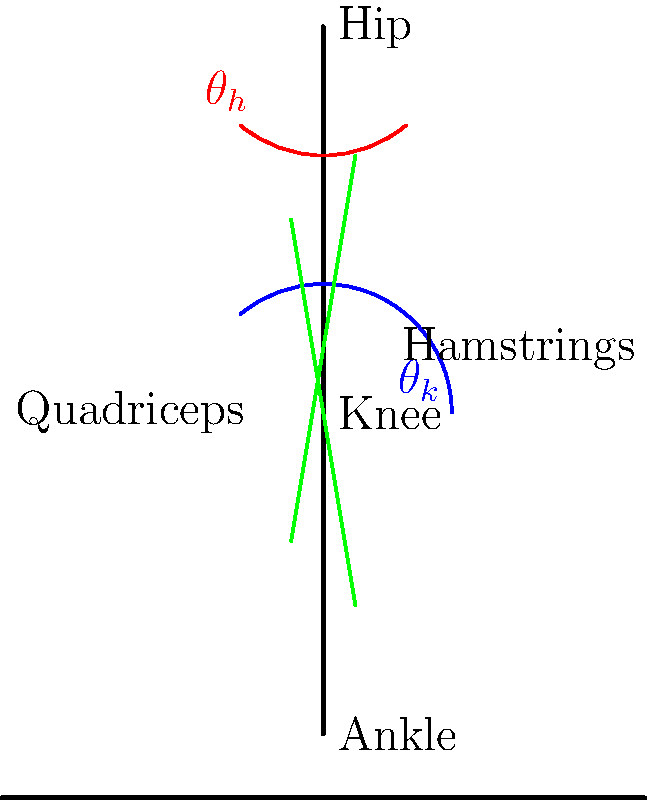In a squat exercise, the knee angle ($\theta_k$) is 130° and the hip angle ($\theta_h$) is 100°. If the quadriceps muscle force is 2000 N, what is the approximate joint reaction force at the knee, assuming the weight of the lower leg is negligible? To solve this problem, we'll use the following steps:

1. Understand the given information:
   - Knee angle ($\theta_k$) = 130°
   - Hip angle ($\theta_h$) = 100°
   - Quadriceps muscle force ($F_q$) = 2000 N

2. Determine the angle between the quadriceps tendon and the femur:
   - This angle is approximately 90° - $\theta_k$/2
   - Angle = 90° - 130°/2 = 25°

3. Calculate the component of the quadriceps force perpendicular to the lower leg:
   - $F_{\perp} = F_q \cdot \cos(25°)$
   - $F_{\perp} = 2000 \cdot \cos(25°) \approx 1812$ N

4. The joint reaction force at the knee is approximately equal to this perpendicular force component, as it must counteract it to maintain equilibrium.

5. Therefore, the joint reaction force at the knee is approximately 1812 N.

Note: This is a simplified calculation that doesn't account for factors such as the patella, other muscle forces, or the exact angle of the quadriceps tendon. In reality, the joint reaction force would be more complex to calculate precisely.
Answer: Approximately 1812 N 